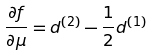<formula> <loc_0><loc_0><loc_500><loc_500>\frac { \partial f } { \partial \mu } = d ^ { ( 2 ) } - \frac { 1 } { 2 } d ^ { ( 1 ) }</formula> 